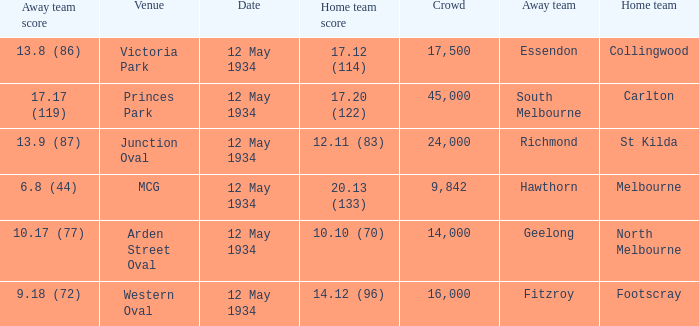What was the home teams score while playing the away team of south melbourne? 17.20 (122). Can you parse all the data within this table? {'header': ['Away team score', 'Venue', 'Date', 'Home team score', 'Crowd', 'Away team', 'Home team'], 'rows': [['13.8 (86)', 'Victoria Park', '12 May 1934', '17.12 (114)', '17,500', 'Essendon', 'Collingwood'], ['17.17 (119)', 'Princes Park', '12 May 1934', '17.20 (122)', '45,000', 'South Melbourne', 'Carlton'], ['13.9 (87)', 'Junction Oval', '12 May 1934', '12.11 (83)', '24,000', 'Richmond', 'St Kilda'], ['6.8 (44)', 'MCG', '12 May 1934', '20.13 (133)', '9,842', 'Hawthorn', 'Melbourne'], ['10.17 (77)', 'Arden Street Oval', '12 May 1934', '10.10 (70)', '14,000', 'Geelong', 'North Melbourne'], ['9.18 (72)', 'Western Oval', '12 May 1934', '14.12 (96)', '16,000', 'Fitzroy', 'Footscray']]} 